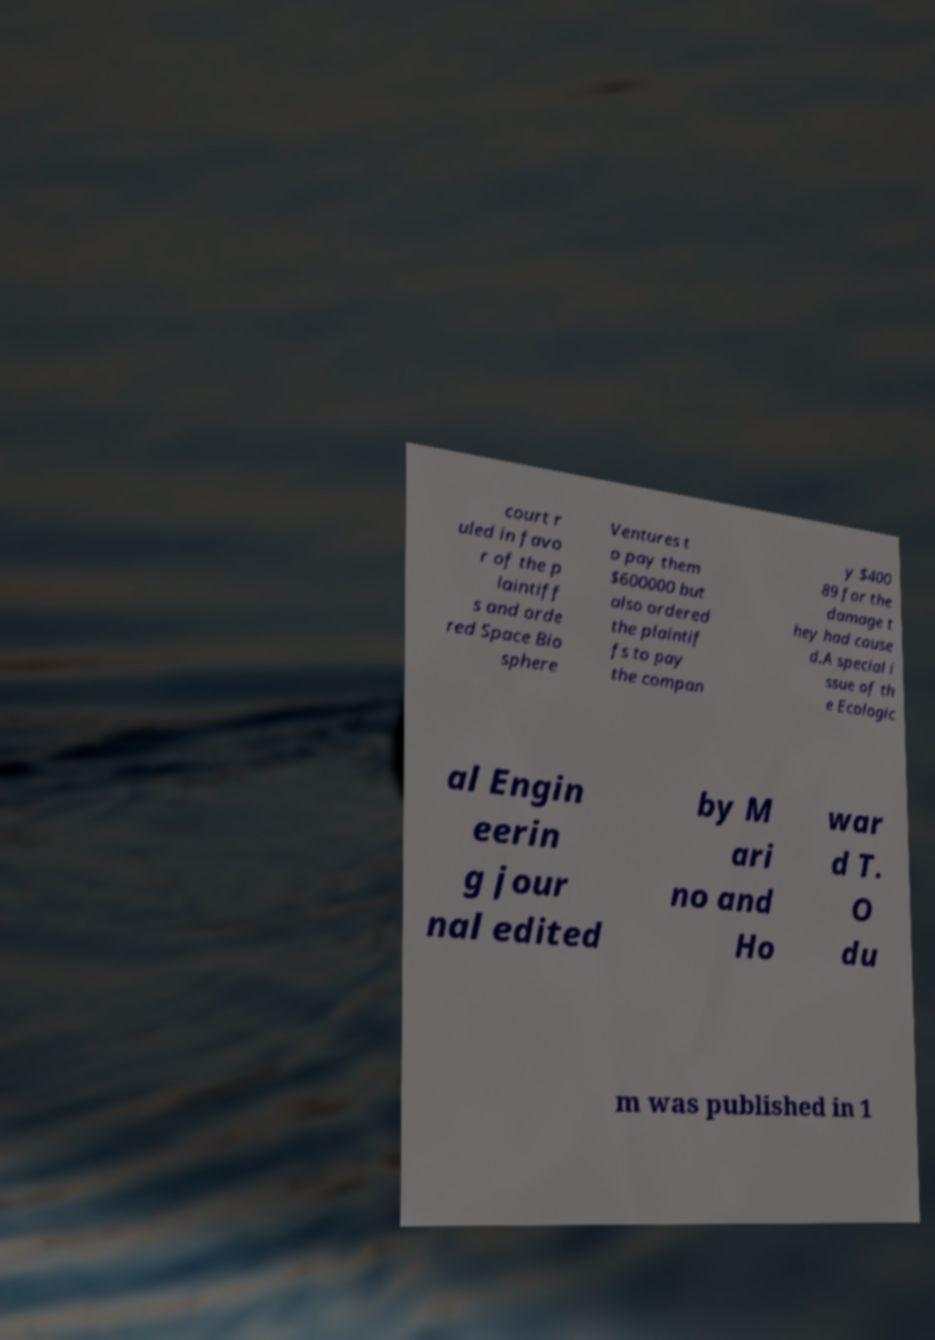Please identify and transcribe the text found in this image. court r uled in favo r of the p laintiff s and orde red Space Bio sphere Ventures t o pay them $600000 but also ordered the plaintif fs to pay the compan y $400 89 for the damage t hey had cause d.A special i ssue of th e Ecologic al Engin eerin g jour nal edited by M ari no and Ho war d T. O du m was published in 1 